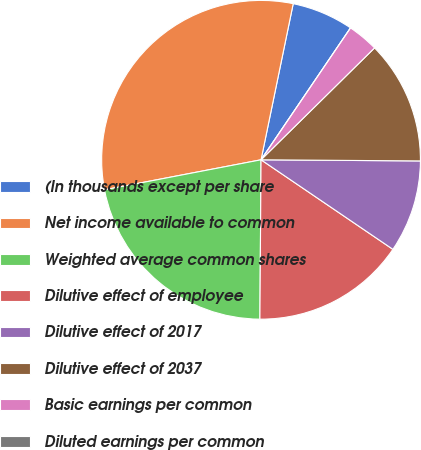Convert chart. <chart><loc_0><loc_0><loc_500><loc_500><pie_chart><fcel>(In thousands except per share<fcel>Net income available to common<fcel>Weighted average common shares<fcel>Dilutive effect of employee<fcel>Dilutive effect of 2017<fcel>Dilutive effect of 2037<fcel>Basic earnings per common<fcel>Diluted earnings per common<nl><fcel>6.25%<fcel>31.25%<fcel>21.87%<fcel>15.62%<fcel>9.38%<fcel>12.5%<fcel>3.13%<fcel>0.0%<nl></chart> 